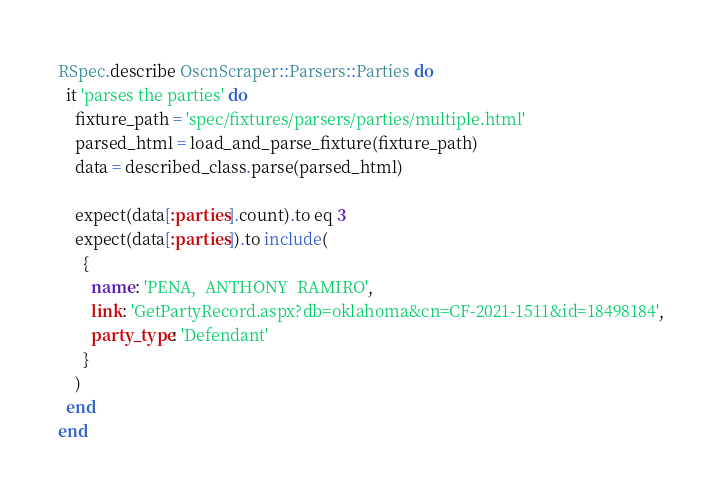Convert code to text. <code><loc_0><loc_0><loc_500><loc_500><_Ruby_>RSpec.describe OscnScraper::Parsers::Parties do
  it 'parses the parties' do
    fixture_path = 'spec/fixtures/parsers/parties/multiple.html'
    parsed_html = load_and_parse_fixture(fixture_path)
    data = described_class.parse(parsed_html)

    expect(data[:parties].count).to eq 3
    expect(data[:parties]).to include(
      {
        name: 'PENA,  ANTHONY  RAMIRO',
        link: 'GetPartyRecord.aspx?db=oklahoma&cn=CF-2021-1511&id=18498184',
        party_type: 'Defendant'
      }
    )
  end
end
</code> 